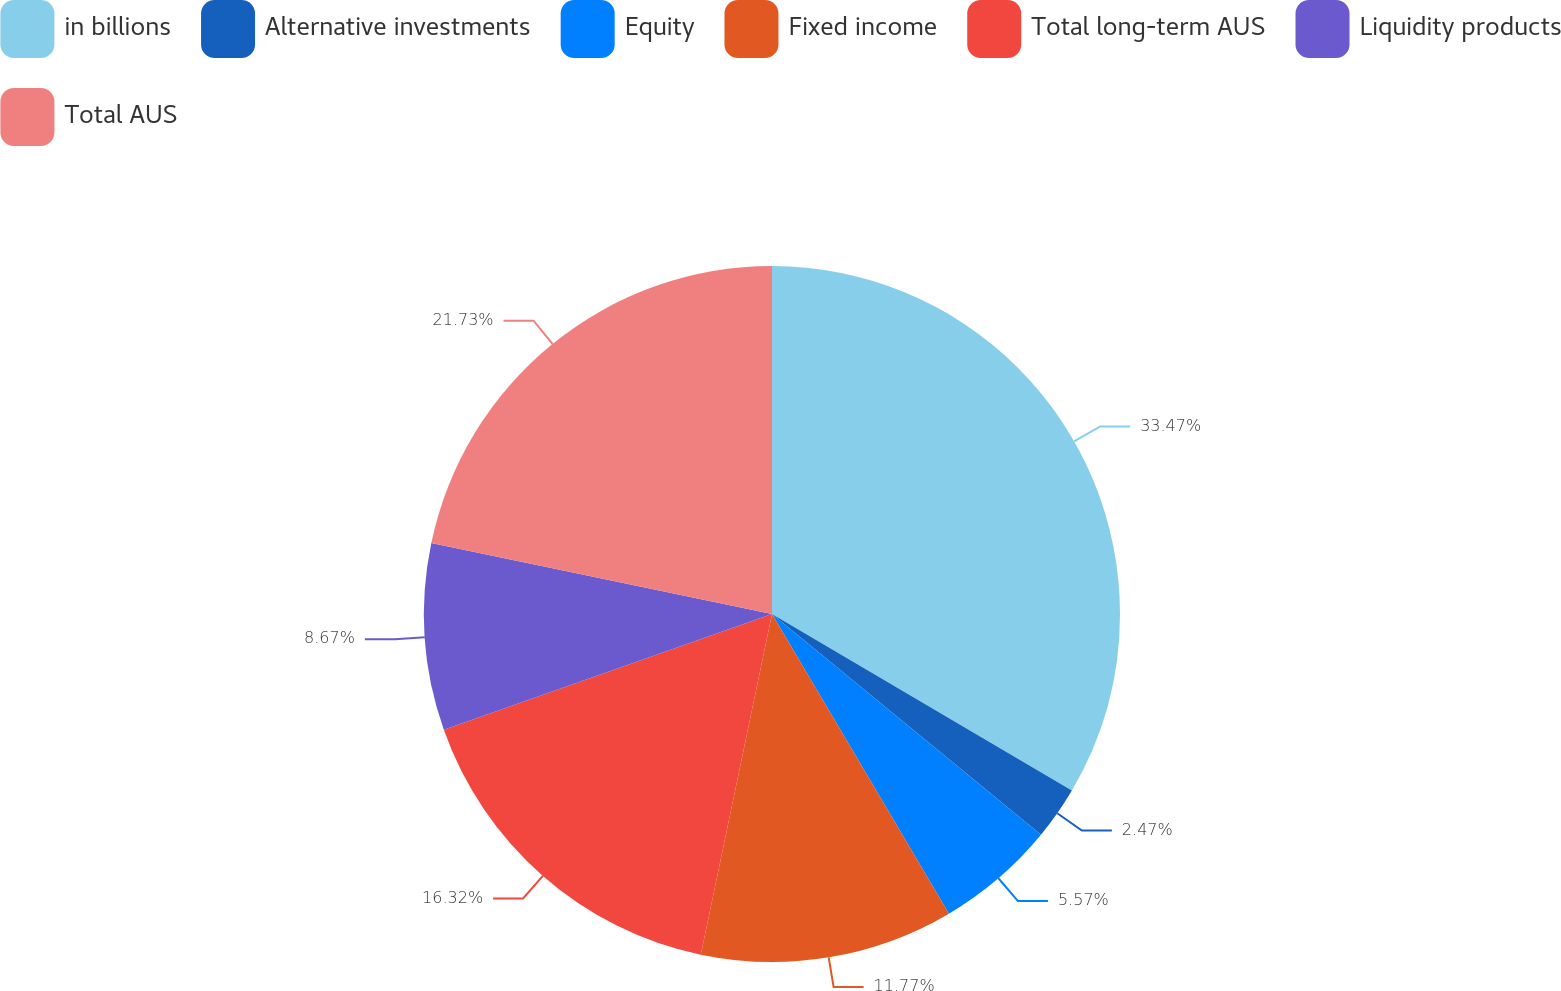Convert chart. <chart><loc_0><loc_0><loc_500><loc_500><pie_chart><fcel>in billions<fcel>Alternative investments<fcel>Equity<fcel>Fixed income<fcel>Total long-term AUS<fcel>Liquidity products<fcel>Total AUS<nl><fcel>33.47%<fcel>2.47%<fcel>5.57%<fcel>11.77%<fcel>16.32%<fcel>8.67%<fcel>21.73%<nl></chart> 